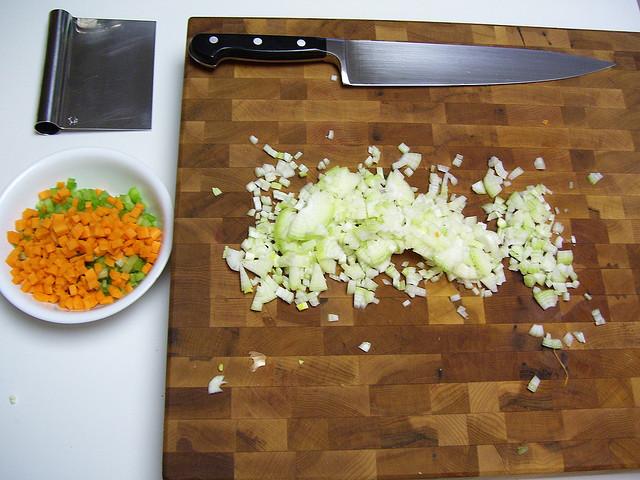Is this a big cutting board?
Write a very short answer. Yes. How many onions?
Quick response, please. 1. What two vegetables are in the white bowl?
Write a very short answer. Carrots and celery. What color is the knife handle?
Quick response, please. Black. 